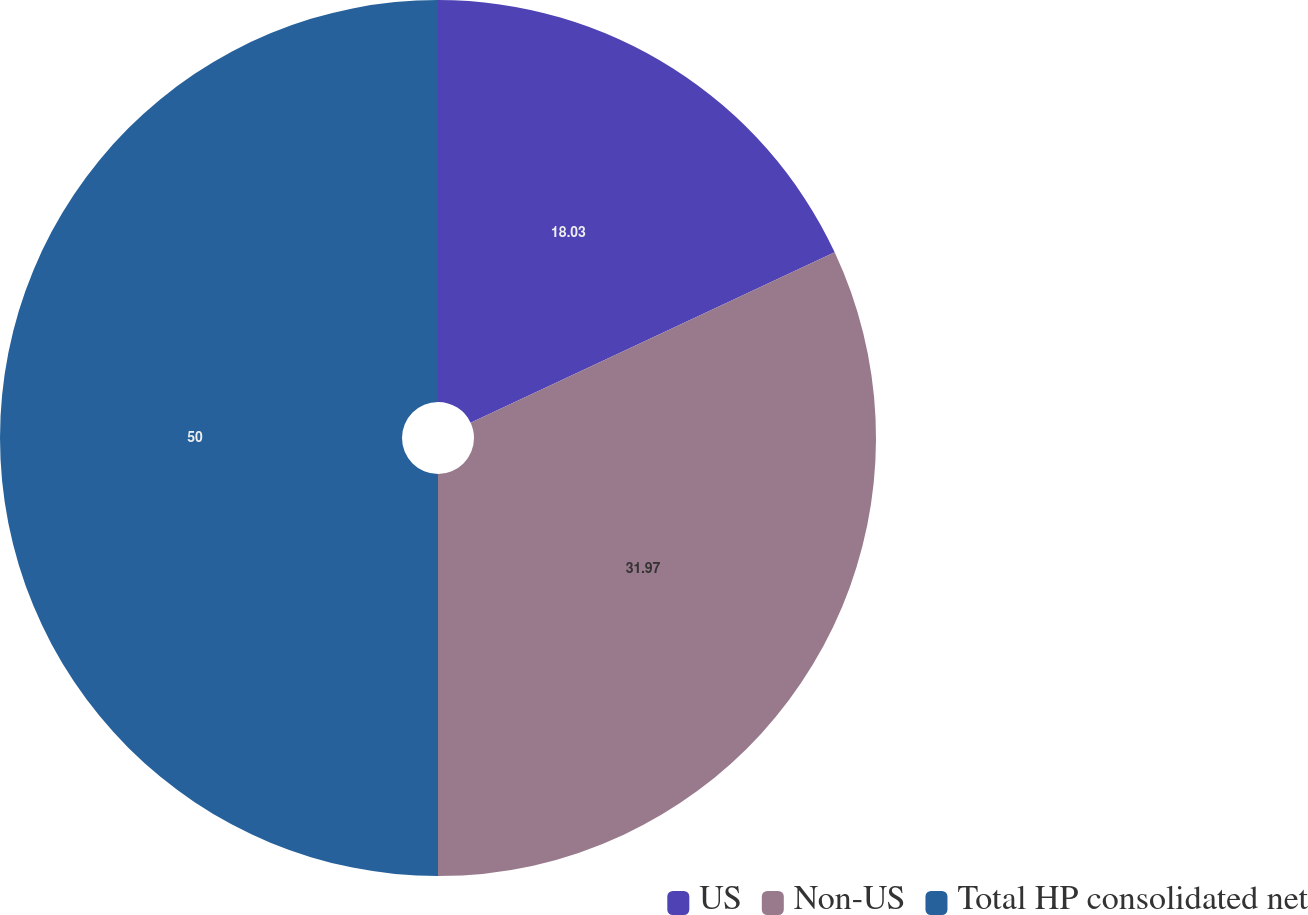<chart> <loc_0><loc_0><loc_500><loc_500><pie_chart><fcel>US<fcel>Non-US<fcel>Total HP consolidated net<nl><fcel>18.03%<fcel>31.97%<fcel>50.0%<nl></chart> 